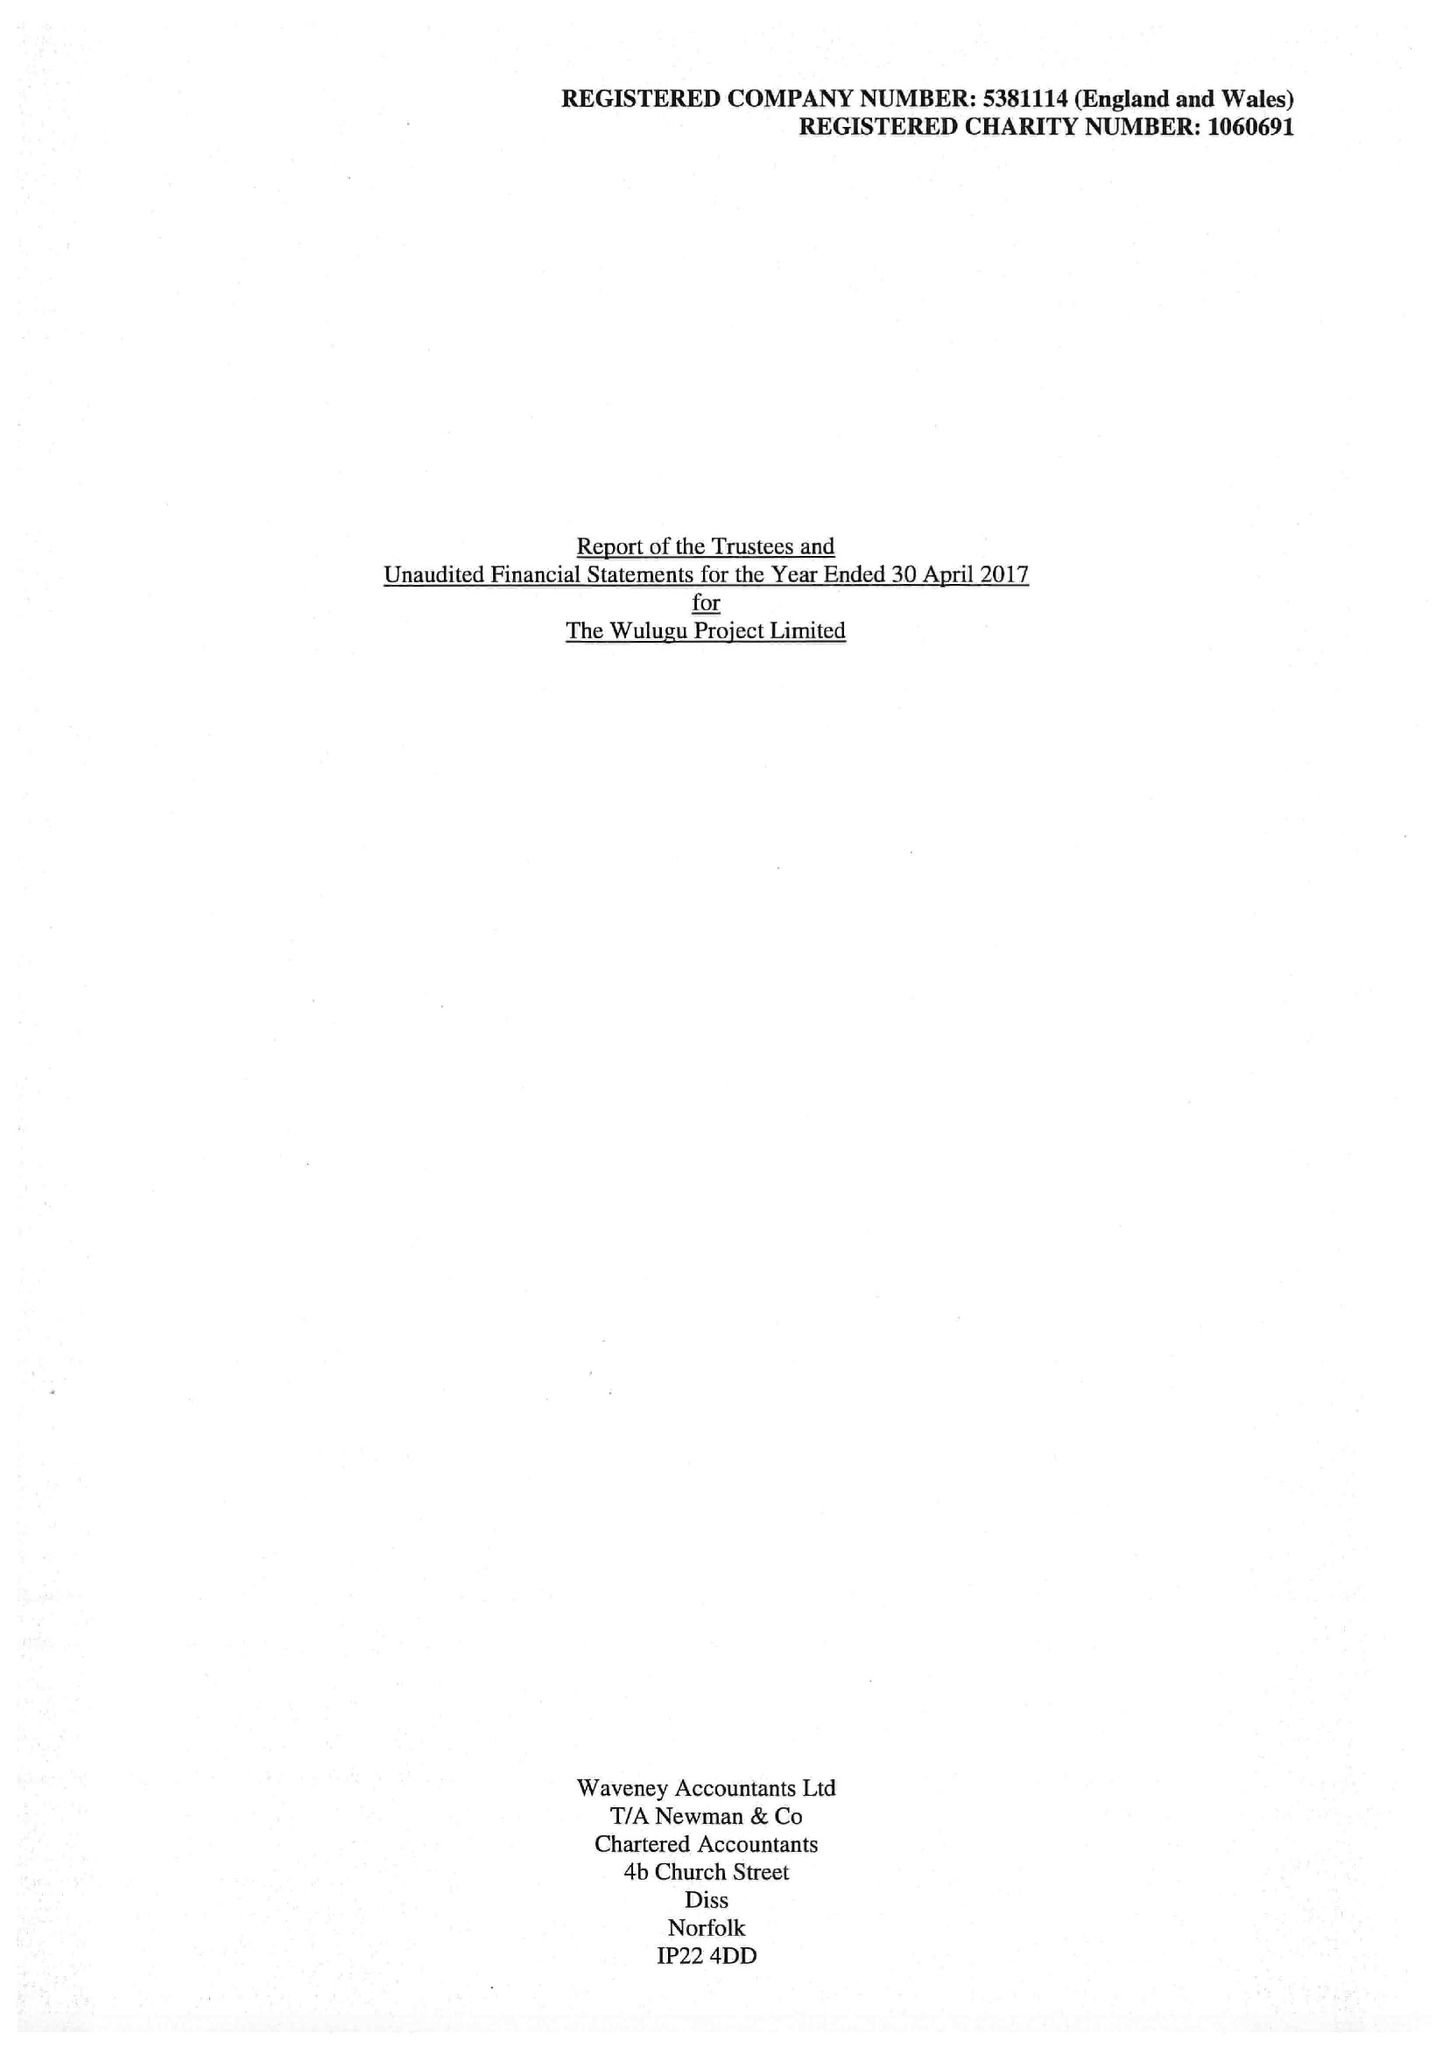What is the value for the address__postcode?
Answer the question using a single word or phrase. NR9 3BH 